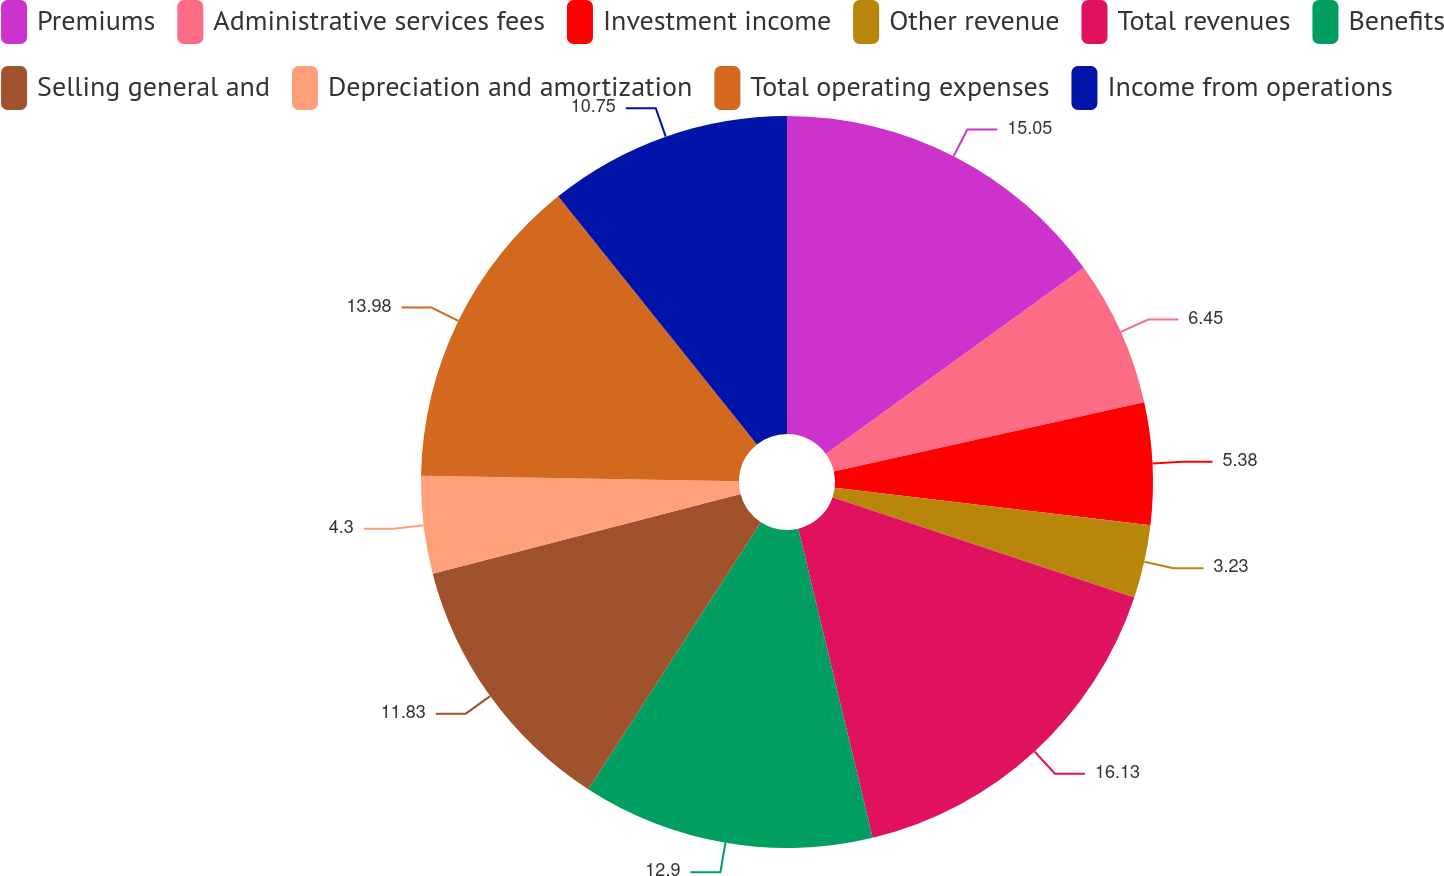Convert chart to OTSL. <chart><loc_0><loc_0><loc_500><loc_500><pie_chart><fcel>Premiums<fcel>Administrative services fees<fcel>Investment income<fcel>Other revenue<fcel>Total revenues<fcel>Benefits<fcel>Selling general and<fcel>Depreciation and amortization<fcel>Total operating expenses<fcel>Income from operations<nl><fcel>15.05%<fcel>6.45%<fcel>5.38%<fcel>3.23%<fcel>16.13%<fcel>12.9%<fcel>11.83%<fcel>4.3%<fcel>13.98%<fcel>10.75%<nl></chart> 